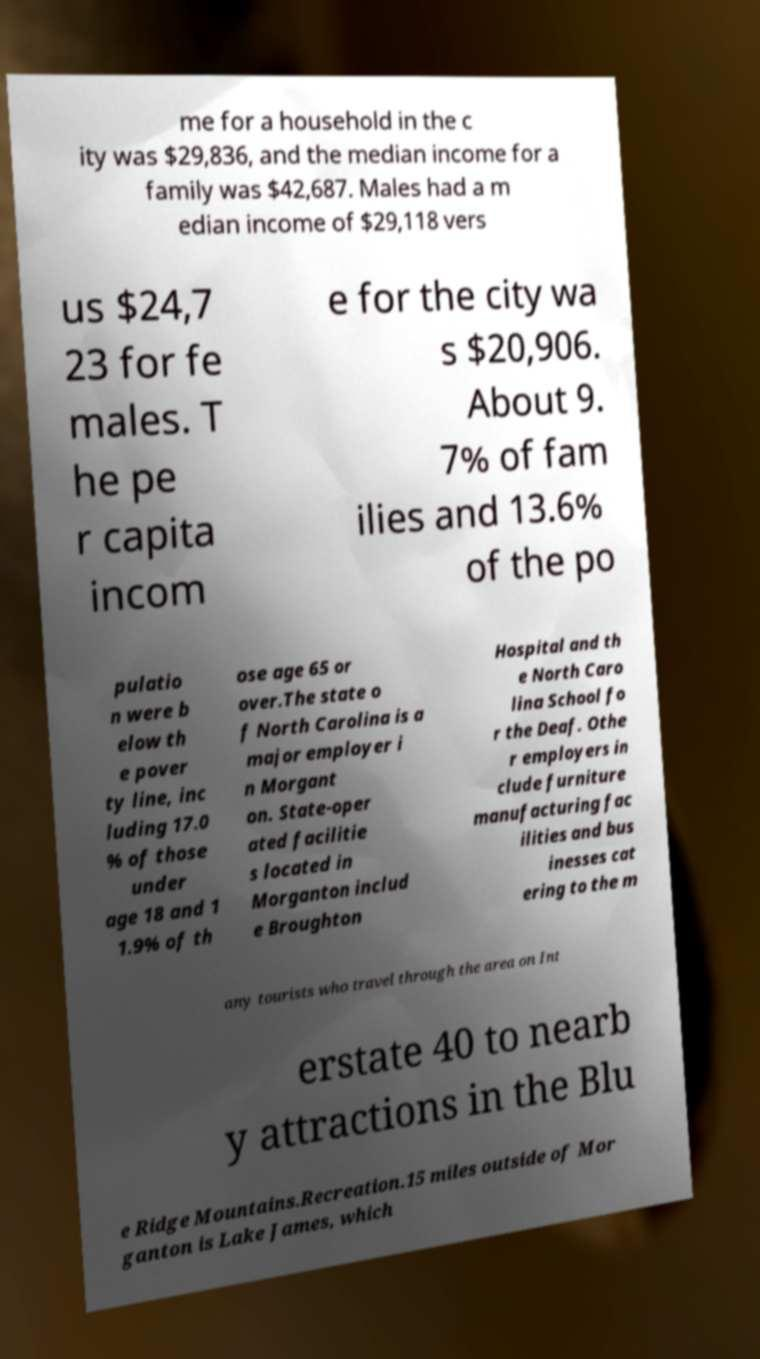Please identify and transcribe the text found in this image. me for a household in the c ity was $29,836, and the median income for a family was $42,687. Males had a m edian income of $29,118 vers us $24,7 23 for fe males. T he pe r capita incom e for the city wa s $20,906. About 9. 7% of fam ilies and 13.6% of the po pulatio n were b elow th e pover ty line, inc luding 17.0 % of those under age 18 and 1 1.9% of th ose age 65 or over.The state o f North Carolina is a major employer i n Morgant on. State-oper ated facilitie s located in Morganton includ e Broughton Hospital and th e North Caro lina School fo r the Deaf. Othe r employers in clude furniture manufacturing fac ilities and bus inesses cat ering to the m any tourists who travel through the area on Int erstate 40 to nearb y attractions in the Blu e Ridge Mountains.Recreation.15 miles outside of Mor ganton is Lake James, which 